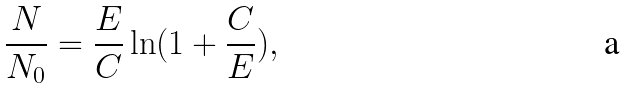<formula> <loc_0><loc_0><loc_500><loc_500>\frac { N } { N _ { 0 } } = \frac { E } { C } \ln ( 1 + \frac { C } { E } ) ,</formula> 